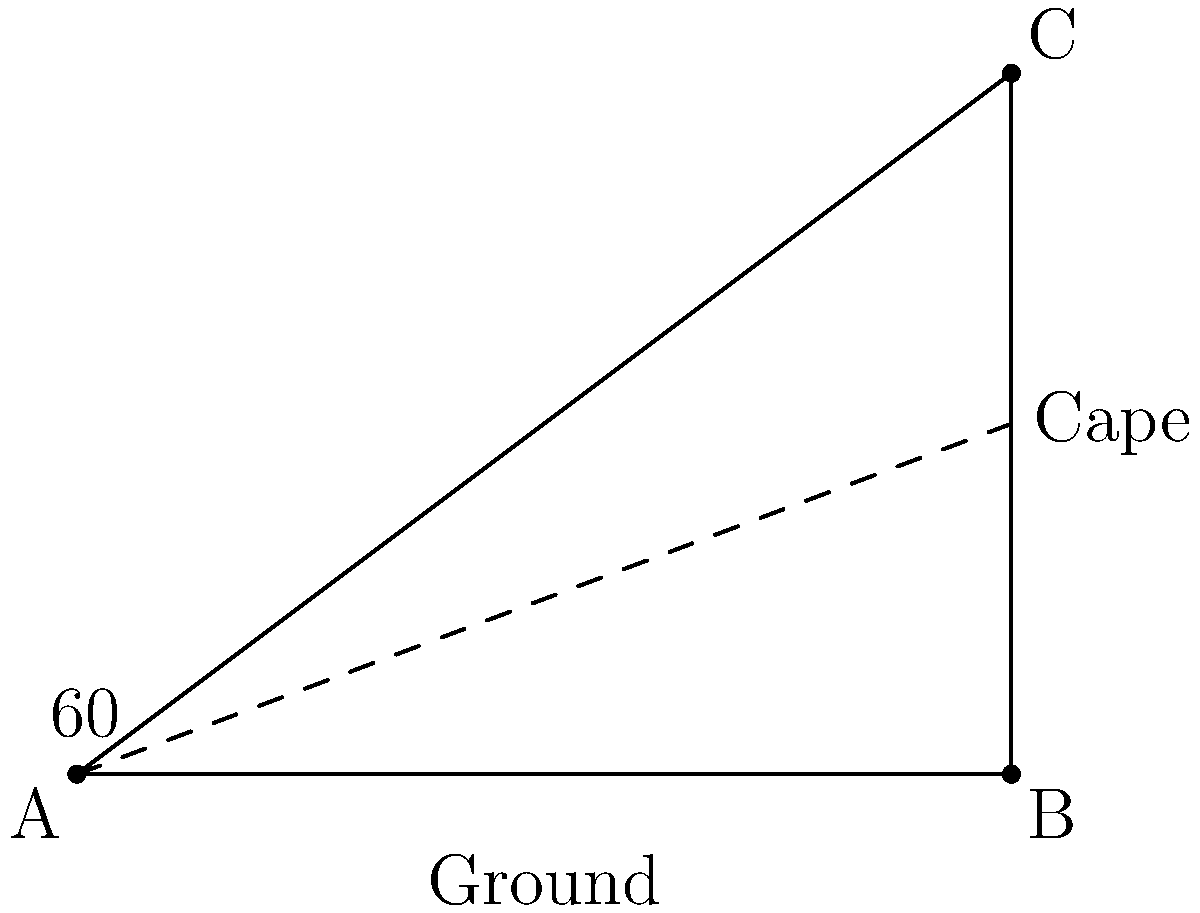As our environmental superhero soars through the sky, their cape forms a 60° angle with the ground. If the cape is 10 meters long, how high above the ground is the superhero flying? Let's approach this step-by-step:

1) We can treat this as a right-angled triangle problem. The cape forms the hypotenuse of the triangle, and we need to find the opposite side (height).

2) In a right-angled triangle, we can use trigonometric ratios. Here, we'll use the sine ratio:

   $\sin(\theta) = \frac{\text{opposite}}{\text{hypotenuse}}$

3) We know:
   - The angle $\theta = 60°$
   - The hypotenuse (cape length) = 10 meters

4) Let's call the height $h$. We can write:

   $\sin(60°) = \frac{h}{10}$

5) We know that $\sin(60°) = \frac{\sqrt{3}}{2}$. So:

   $\frac{\sqrt{3}}{2} = \frac{h}{10}$

6) Solve for $h$:
   
   $h = 10 \cdot \frac{\sqrt{3}}{2} = 5\sqrt{3}$ meters

7) If we want to approximate this:
   
   $5\sqrt{3} \approx 8.66$ meters

Therefore, the superhero is flying approximately 8.66 meters above the ground.
Answer: $5\sqrt{3}$ meters 